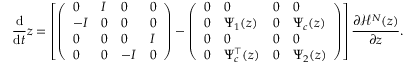Convert formula to latex. <formula><loc_0><loc_0><loc_500><loc_500>\frac { \mathrm d } { \mathrm d t } z = \left [ \left ( \begin{array} { l l l l } { 0 } & { I } & { 0 } & { 0 } \\ { - I } & { 0 } & { 0 } & { 0 } \\ { 0 } & { 0 } & { 0 } & { I } \\ { 0 } & { 0 } & { - I } & { 0 } \end{array} \right ) - \left ( \begin{array} { l l l l } { 0 } & { 0 } & { 0 } & { 0 } \\ { 0 } & { \Psi _ { 1 } ( z ) } & { 0 } & { \Psi _ { c } ( z ) } \\ { 0 } & { 0 } & { 0 } & { 0 } \\ { 0 } & { \Psi _ { c } ^ { \top } ( z ) } & { 0 } & { \Psi _ { 2 } ( z ) } \end{array} \right ) \right ] \frac { \partial \mathcal { H } ^ { N } ( z ) } { \partial z } .</formula> 